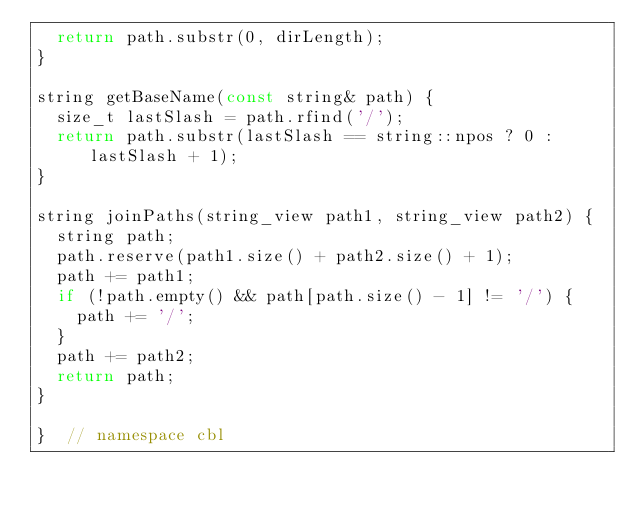Convert code to text. <code><loc_0><loc_0><loc_500><loc_500><_C++_>  return path.substr(0, dirLength);
}

string getBaseName(const string& path) {
  size_t lastSlash = path.rfind('/');
  return path.substr(lastSlash == string::npos ? 0 : lastSlash + 1);
}

string joinPaths(string_view path1, string_view path2) {
  string path;
  path.reserve(path1.size() + path2.size() + 1);
  path += path1;
  if (!path.empty() && path[path.size() - 1] != '/') {
    path += '/';
  }
  path += path2;
  return path;
}

}  // namespace cbl
</code> 